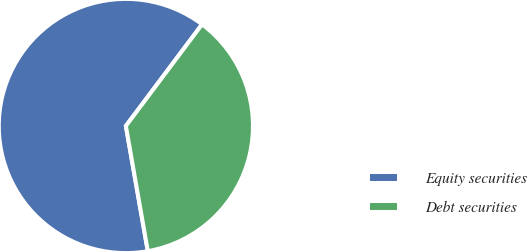Convert chart to OTSL. <chart><loc_0><loc_0><loc_500><loc_500><pie_chart><fcel>Equity securities<fcel>Debt securities<nl><fcel>63.0%<fcel>37.0%<nl></chart> 